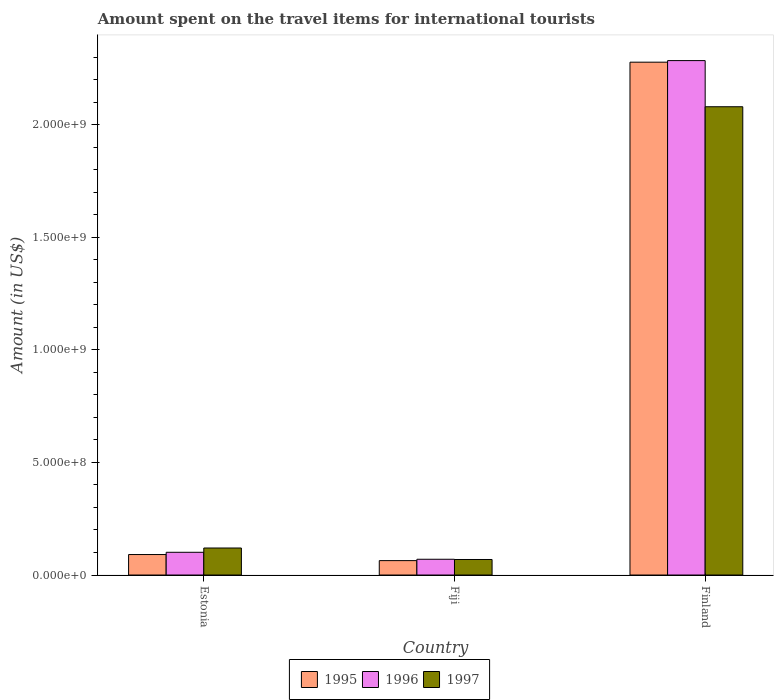How many different coloured bars are there?
Offer a very short reply. 3. Are the number of bars per tick equal to the number of legend labels?
Make the answer very short. Yes. How many bars are there on the 2nd tick from the right?
Ensure brevity in your answer.  3. What is the label of the 1st group of bars from the left?
Your answer should be compact. Estonia. In how many cases, is the number of bars for a given country not equal to the number of legend labels?
Give a very brief answer. 0. What is the amount spent on the travel items for international tourists in 1995 in Fiji?
Your answer should be compact. 6.40e+07. Across all countries, what is the maximum amount spent on the travel items for international tourists in 1995?
Your answer should be compact. 2.28e+09. Across all countries, what is the minimum amount spent on the travel items for international tourists in 1995?
Keep it short and to the point. 6.40e+07. In which country was the amount spent on the travel items for international tourists in 1995 maximum?
Keep it short and to the point. Finland. In which country was the amount spent on the travel items for international tourists in 1997 minimum?
Make the answer very short. Fiji. What is the total amount spent on the travel items for international tourists in 1995 in the graph?
Make the answer very short. 2.43e+09. What is the difference between the amount spent on the travel items for international tourists in 1995 in Estonia and that in Fiji?
Provide a short and direct response. 2.70e+07. What is the difference between the amount spent on the travel items for international tourists in 1996 in Estonia and the amount spent on the travel items for international tourists in 1995 in Fiji?
Your response must be concise. 3.70e+07. What is the average amount spent on the travel items for international tourists in 1995 per country?
Offer a very short reply. 8.11e+08. What is the difference between the amount spent on the travel items for international tourists of/in 1997 and amount spent on the travel items for international tourists of/in 1996 in Finland?
Give a very brief answer. -2.05e+08. In how many countries, is the amount spent on the travel items for international tourists in 1996 greater than 300000000 US$?
Make the answer very short. 1. What is the ratio of the amount spent on the travel items for international tourists in 1995 in Estonia to that in Finland?
Your answer should be very brief. 0.04. Is the amount spent on the travel items for international tourists in 1997 in Fiji less than that in Finland?
Provide a short and direct response. Yes. Is the difference between the amount spent on the travel items for international tourists in 1997 in Fiji and Finland greater than the difference between the amount spent on the travel items for international tourists in 1996 in Fiji and Finland?
Your response must be concise. Yes. What is the difference between the highest and the second highest amount spent on the travel items for international tourists in 1995?
Offer a very short reply. 2.21e+09. What is the difference between the highest and the lowest amount spent on the travel items for international tourists in 1996?
Give a very brief answer. 2.22e+09. In how many countries, is the amount spent on the travel items for international tourists in 1996 greater than the average amount spent on the travel items for international tourists in 1996 taken over all countries?
Your response must be concise. 1. Is the sum of the amount spent on the travel items for international tourists in 1997 in Estonia and Finland greater than the maximum amount spent on the travel items for international tourists in 1996 across all countries?
Give a very brief answer. No. What does the 2nd bar from the left in Finland represents?
Your answer should be compact. 1996. What is the difference between two consecutive major ticks on the Y-axis?
Offer a terse response. 5.00e+08. Does the graph contain grids?
Give a very brief answer. No. Where does the legend appear in the graph?
Your answer should be very brief. Bottom center. How many legend labels are there?
Provide a succinct answer. 3. How are the legend labels stacked?
Offer a terse response. Horizontal. What is the title of the graph?
Ensure brevity in your answer.  Amount spent on the travel items for international tourists. What is the label or title of the X-axis?
Ensure brevity in your answer.  Country. What is the label or title of the Y-axis?
Offer a very short reply. Amount (in US$). What is the Amount (in US$) in 1995 in Estonia?
Give a very brief answer. 9.10e+07. What is the Amount (in US$) of 1996 in Estonia?
Ensure brevity in your answer.  1.01e+08. What is the Amount (in US$) of 1997 in Estonia?
Offer a terse response. 1.20e+08. What is the Amount (in US$) of 1995 in Fiji?
Your response must be concise. 6.40e+07. What is the Amount (in US$) in 1996 in Fiji?
Your response must be concise. 7.00e+07. What is the Amount (in US$) in 1997 in Fiji?
Make the answer very short. 6.90e+07. What is the Amount (in US$) in 1995 in Finland?
Ensure brevity in your answer.  2.28e+09. What is the Amount (in US$) in 1996 in Finland?
Offer a very short reply. 2.28e+09. What is the Amount (in US$) in 1997 in Finland?
Offer a very short reply. 2.08e+09. Across all countries, what is the maximum Amount (in US$) of 1995?
Give a very brief answer. 2.28e+09. Across all countries, what is the maximum Amount (in US$) of 1996?
Keep it short and to the point. 2.28e+09. Across all countries, what is the maximum Amount (in US$) in 1997?
Give a very brief answer. 2.08e+09. Across all countries, what is the minimum Amount (in US$) of 1995?
Your answer should be very brief. 6.40e+07. Across all countries, what is the minimum Amount (in US$) in 1996?
Your response must be concise. 7.00e+07. Across all countries, what is the minimum Amount (in US$) of 1997?
Offer a very short reply. 6.90e+07. What is the total Amount (in US$) in 1995 in the graph?
Provide a succinct answer. 2.43e+09. What is the total Amount (in US$) in 1996 in the graph?
Provide a succinct answer. 2.46e+09. What is the total Amount (in US$) of 1997 in the graph?
Make the answer very short. 2.27e+09. What is the difference between the Amount (in US$) of 1995 in Estonia and that in Fiji?
Your answer should be compact. 2.70e+07. What is the difference between the Amount (in US$) of 1996 in Estonia and that in Fiji?
Provide a short and direct response. 3.10e+07. What is the difference between the Amount (in US$) of 1997 in Estonia and that in Fiji?
Offer a terse response. 5.10e+07. What is the difference between the Amount (in US$) of 1995 in Estonia and that in Finland?
Offer a terse response. -2.19e+09. What is the difference between the Amount (in US$) of 1996 in Estonia and that in Finland?
Your answer should be compact. -2.18e+09. What is the difference between the Amount (in US$) of 1997 in Estonia and that in Finland?
Ensure brevity in your answer.  -1.96e+09. What is the difference between the Amount (in US$) in 1995 in Fiji and that in Finland?
Your answer should be compact. -2.21e+09. What is the difference between the Amount (in US$) of 1996 in Fiji and that in Finland?
Make the answer very short. -2.22e+09. What is the difference between the Amount (in US$) of 1997 in Fiji and that in Finland?
Keep it short and to the point. -2.01e+09. What is the difference between the Amount (in US$) in 1995 in Estonia and the Amount (in US$) in 1996 in Fiji?
Provide a succinct answer. 2.10e+07. What is the difference between the Amount (in US$) of 1995 in Estonia and the Amount (in US$) of 1997 in Fiji?
Make the answer very short. 2.20e+07. What is the difference between the Amount (in US$) of 1996 in Estonia and the Amount (in US$) of 1997 in Fiji?
Provide a succinct answer. 3.20e+07. What is the difference between the Amount (in US$) in 1995 in Estonia and the Amount (in US$) in 1996 in Finland?
Your answer should be very brief. -2.19e+09. What is the difference between the Amount (in US$) in 1995 in Estonia and the Amount (in US$) in 1997 in Finland?
Your answer should be very brief. -1.99e+09. What is the difference between the Amount (in US$) in 1996 in Estonia and the Amount (in US$) in 1997 in Finland?
Provide a succinct answer. -1.98e+09. What is the difference between the Amount (in US$) of 1995 in Fiji and the Amount (in US$) of 1996 in Finland?
Provide a succinct answer. -2.22e+09. What is the difference between the Amount (in US$) of 1995 in Fiji and the Amount (in US$) of 1997 in Finland?
Keep it short and to the point. -2.02e+09. What is the difference between the Amount (in US$) of 1996 in Fiji and the Amount (in US$) of 1997 in Finland?
Give a very brief answer. -2.01e+09. What is the average Amount (in US$) in 1995 per country?
Your response must be concise. 8.11e+08. What is the average Amount (in US$) of 1996 per country?
Your answer should be very brief. 8.19e+08. What is the average Amount (in US$) in 1997 per country?
Ensure brevity in your answer.  7.56e+08. What is the difference between the Amount (in US$) of 1995 and Amount (in US$) of 1996 in Estonia?
Keep it short and to the point. -1.00e+07. What is the difference between the Amount (in US$) of 1995 and Amount (in US$) of 1997 in Estonia?
Ensure brevity in your answer.  -2.90e+07. What is the difference between the Amount (in US$) in 1996 and Amount (in US$) in 1997 in Estonia?
Provide a short and direct response. -1.90e+07. What is the difference between the Amount (in US$) of 1995 and Amount (in US$) of 1996 in Fiji?
Offer a terse response. -6.00e+06. What is the difference between the Amount (in US$) in 1995 and Amount (in US$) in 1997 in Fiji?
Provide a short and direct response. -5.00e+06. What is the difference between the Amount (in US$) in 1996 and Amount (in US$) in 1997 in Fiji?
Provide a succinct answer. 1.00e+06. What is the difference between the Amount (in US$) of 1995 and Amount (in US$) of 1996 in Finland?
Ensure brevity in your answer.  -7.00e+06. What is the difference between the Amount (in US$) in 1995 and Amount (in US$) in 1997 in Finland?
Your response must be concise. 1.98e+08. What is the difference between the Amount (in US$) in 1996 and Amount (in US$) in 1997 in Finland?
Give a very brief answer. 2.05e+08. What is the ratio of the Amount (in US$) of 1995 in Estonia to that in Fiji?
Your answer should be very brief. 1.42. What is the ratio of the Amount (in US$) in 1996 in Estonia to that in Fiji?
Offer a very short reply. 1.44. What is the ratio of the Amount (in US$) in 1997 in Estonia to that in Fiji?
Your answer should be very brief. 1.74. What is the ratio of the Amount (in US$) of 1995 in Estonia to that in Finland?
Your answer should be very brief. 0.04. What is the ratio of the Amount (in US$) in 1996 in Estonia to that in Finland?
Give a very brief answer. 0.04. What is the ratio of the Amount (in US$) of 1997 in Estonia to that in Finland?
Ensure brevity in your answer.  0.06. What is the ratio of the Amount (in US$) of 1995 in Fiji to that in Finland?
Your answer should be compact. 0.03. What is the ratio of the Amount (in US$) in 1996 in Fiji to that in Finland?
Make the answer very short. 0.03. What is the ratio of the Amount (in US$) in 1997 in Fiji to that in Finland?
Offer a terse response. 0.03. What is the difference between the highest and the second highest Amount (in US$) in 1995?
Keep it short and to the point. 2.19e+09. What is the difference between the highest and the second highest Amount (in US$) in 1996?
Your answer should be compact. 2.18e+09. What is the difference between the highest and the second highest Amount (in US$) of 1997?
Make the answer very short. 1.96e+09. What is the difference between the highest and the lowest Amount (in US$) in 1995?
Your answer should be very brief. 2.21e+09. What is the difference between the highest and the lowest Amount (in US$) of 1996?
Keep it short and to the point. 2.22e+09. What is the difference between the highest and the lowest Amount (in US$) in 1997?
Provide a succinct answer. 2.01e+09. 